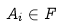Convert formula to latex. <formula><loc_0><loc_0><loc_500><loc_500>A _ { i } \in F</formula> 